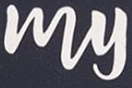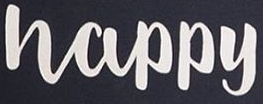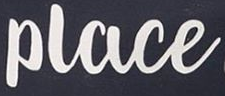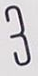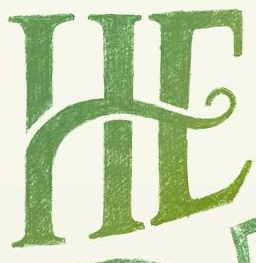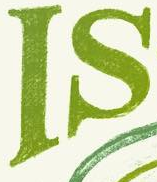What words can you see in these images in sequence, separated by a semicolon? My; Happy; Place; 3; HE; IS 